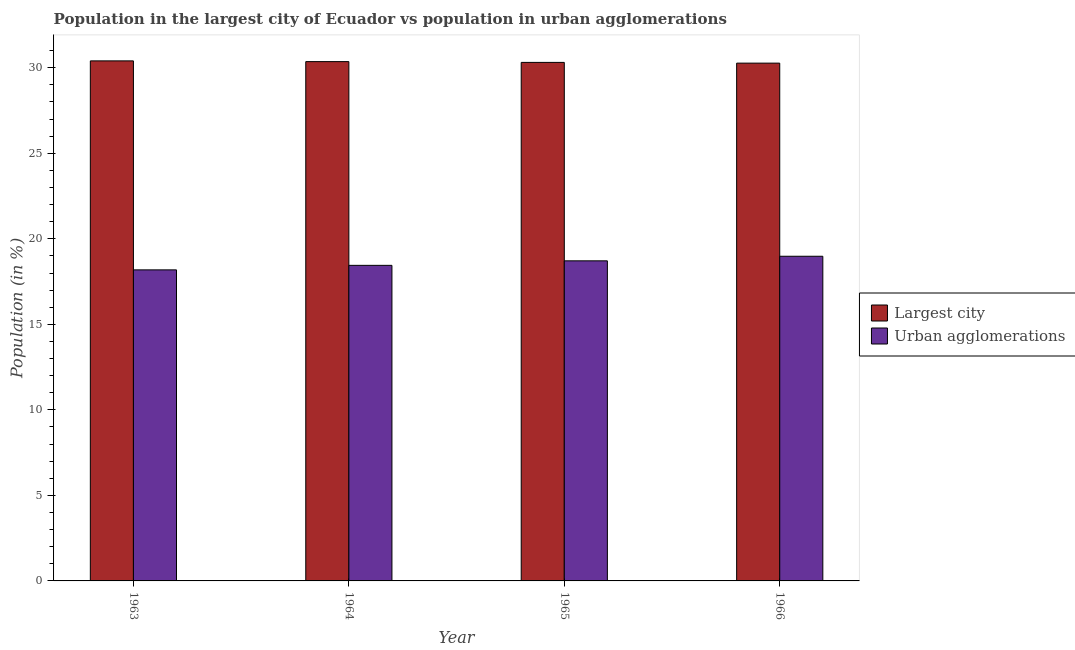How many different coloured bars are there?
Your answer should be very brief. 2. How many groups of bars are there?
Your answer should be compact. 4. Are the number of bars on each tick of the X-axis equal?
Your answer should be compact. Yes. How many bars are there on the 2nd tick from the left?
Give a very brief answer. 2. What is the population in urban agglomerations in 1966?
Provide a short and direct response. 18.98. Across all years, what is the maximum population in the largest city?
Provide a succinct answer. 30.4. Across all years, what is the minimum population in the largest city?
Offer a terse response. 30.27. What is the total population in the largest city in the graph?
Ensure brevity in your answer.  121.34. What is the difference between the population in urban agglomerations in 1964 and that in 1965?
Ensure brevity in your answer.  -0.26. What is the difference between the population in the largest city in 1965 and the population in urban agglomerations in 1964?
Your answer should be very brief. -0.05. What is the average population in urban agglomerations per year?
Offer a terse response. 18.58. In how many years, is the population in the largest city greater than 18 %?
Your answer should be very brief. 4. What is the ratio of the population in urban agglomerations in 1963 to that in 1966?
Ensure brevity in your answer.  0.96. What is the difference between the highest and the second highest population in urban agglomerations?
Offer a terse response. 0.27. What is the difference between the highest and the lowest population in urban agglomerations?
Provide a succinct answer. 0.8. What does the 2nd bar from the left in 1966 represents?
Your answer should be very brief. Urban agglomerations. What does the 2nd bar from the right in 1963 represents?
Make the answer very short. Largest city. Are all the bars in the graph horizontal?
Your answer should be very brief. No. How many years are there in the graph?
Your response must be concise. 4. Does the graph contain any zero values?
Offer a terse response. No. Where does the legend appear in the graph?
Ensure brevity in your answer.  Center right. How are the legend labels stacked?
Provide a succinct answer. Vertical. What is the title of the graph?
Your answer should be compact. Population in the largest city of Ecuador vs population in urban agglomerations. Does "Researchers" appear as one of the legend labels in the graph?
Ensure brevity in your answer.  No. What is the label or title of the X-axis?
Keep it short and to the point. Year. What is the Population (in %) of Largest city in 1963?
Make the answer very short. 30.4. What is the Population (in %) of Urban agglomerations in 1963?
Your response must be concise. 18.18. What is the Population (in %) of Largest city in 1964?
Your answer should be compact. 30.36. What is the Population (in %) of Urban agglomerations in 1964?
Offer a very short reply. 18.45. What is the Population (in %) of Largest city in 1965?
Your answer should be compact. 30.31. What is the Population (in %) of Urban agglomerations in 1965?
Offer a terse response. 18.71. What is the Population (in %) of Largest city in 1966?
Make the answer very short. 30.27. What is the Population (in %) of Urban agglomerations in 1966?
Offer a very short reply. 18.98. Across all years, what is the maximum Population (in %) of Largest city?
Provide a succinct answer. 30.4. Across all years, what is the maximum Population (in %) in Urban agglomerations?
Give a very brief answer. 18.98. Across all years, what is the minimum Population (in %) of Largest city?
Offer a very short reply. 30.27. Across all years, what is the minimum Population (in %) of Urban agglomerations?
Provide a succinct answer. 18.18. What is the total Population (in %) in Largest city in the graph?
Your response must be concise. 121.34. What is the total Population (in %) in Urban agglomerations in the graph?
Make the answer very short. 74.32. What is the difference between the Population (in %) in Largest city in 1963 and that in 1964?
Give a very brief answer. 0.04. What is the difference between the Population (in %) in Urban agglomerations in 1963 and that in 1964?
Provide a short and direct response. -0.26. What is the difference between the Population (in %) in Largest city in 1963 and that in 1965?
Make the answer very short. 0.09. What is the difference between the Population (in %) of Urban agglomerations in 1963 and that in 1965?
Make the answer very short. -0.53. What is the difference between the Population (in %) of Largest city in 1963 and that in 1966?
Offer a very short reply. 0.13. What is the difference between the Population (in %) of Urban agglomerations in 1963 and that in 1966?
Your answer should be very brief. -0.8. What is the difference between the Population (in %) in Largest city in 1964 and that in 1965?
Provide a short and direct response. 0.05. What is the difference between the Population (in %) of Urban agglomerations in 1964 and that in 1965?
Your answer should be very brief. -0.26. What is the difference between the Population (in %) of Largest city in 1964 and that in 1966?
Keep it short and to the point. 0.09. What is the difference between the Population (in %) of Urban agglomerations in 1964 and that in 1966?
Offer a terse response. -0.53. What is the difference between the Population (in %) in Largest city in 1965 and that in 1966?
Your answer should be compact. 0.04. What is the difference between the Population (in %) of Urban agglomerations in 1965 and that in 1966?
Keep it short and to the point. -0.27. What is the difference between the Population (in %) of Largest city in 1963 and the Population (in %) of Urban agglomerations in 1964?
Your answer should be compact. 11.95. What is the difference between the Population (in %) of Largest city in 1963 and the Population (in %) of Urban agglomerations in 1965?
Provide a succinct answer. 11.69. What is the difference between the Population (in %) in Largest city in 1963 and the Population (in %) in Urban agglomerations in 1966?
Give a very brief answer. 11.42. What is the difference between the Population (in %) in Largest city in 1964 and the Population (in %) in Urban agglomerations in 1965?
Ensure brevity in your answer.  11.65. What is the difference between the Population (in %) of Largest city in 1964 and the Population (in %) of Urban agglomerations in 1966?
Offer a very short reply. 11.38. What is the difference between the Population (in %) in Largest city in 1965 and the Population (in %) in Urban agglomerations in 1966?
Your answer should be very brief. 11.33. What is the average Population (in %) of Largest city per year?
Make the answer very short. 30.33. What is the average Population (in %) of Urban agglomerations per year?
Make the answer very short. 18.58. In the year 1963, what is the difference between the Population (in %) of Largest city and Population (in %) of Urban agglomerations?
Provide a succinct answer. 12.22. In the year 1964, what is the difference between the Population (in %) in Largest city and Population (in %) in Urban agglomerations?
Your response must be concise. 11.91. In the year 1965, what is the difference between the Population (in %) in Largest city and Population (in %) in Urban agglomerations?
Your answer should be compact. 11.6. In the year 1966, what is the difference between the Population (in %) in Largest city and Population (in %) in Urban agglomerations?
Provide a succinct answer. 11.29. What is the ratio of the Population (in %) of Largest city in 1963 to that in 1964?
Ensure brevity in your answer.  1. What is the ratio of the Population (in %) in Urban agglomerations in 1963 to that in 1964?
Provide a short and direct response. 0.99. What is the ratio of the Population (in %) of Largest city in 1963 to that in 1965?
Ensure brevity in your answer.  1. What is the ratio of the Population (in %) in Urban agglomerations in 1963 to that in 1965?
Make the answer very short. 0.97. What is the ratio of the Population (in %) of Urban agglomerations in 1963 to that in 1966?
Give a very brief answer. 0.96. What is the ratio of the Population (in %) of Urban agglomerations in 1964 to that in 1965?
Offer a very short reply. 0.99. What is the ratio of the Population (in %) of Largest city in 1964 to that in 1966?
Provide a succinct answer. 1. What is the ratio of the Population (in %) of Largest city in 1965 to that in 1966?
Make the answer very short. 1. What is the ratio of the Population (in %) of Urban agglomerations in 1965 to that in 1966?
Your response must be concise. 0.99. What is the difference between the highest and the second highest Population (in %) of Largest city?
Offer a very short reply. 0.04. What is the difference between the highest and the second highest Population (in %) in Urban agglomerations?
Your answer should be compact. 0.27. What is the difference between the highest and the lowest Population (in %) in Largest city?
Provide a short and direct response. 0.13. What is the difference between the highest and the lowest Population (in %) in Urban agglomerations?
Ensure brevity in your answer.  0.8. 